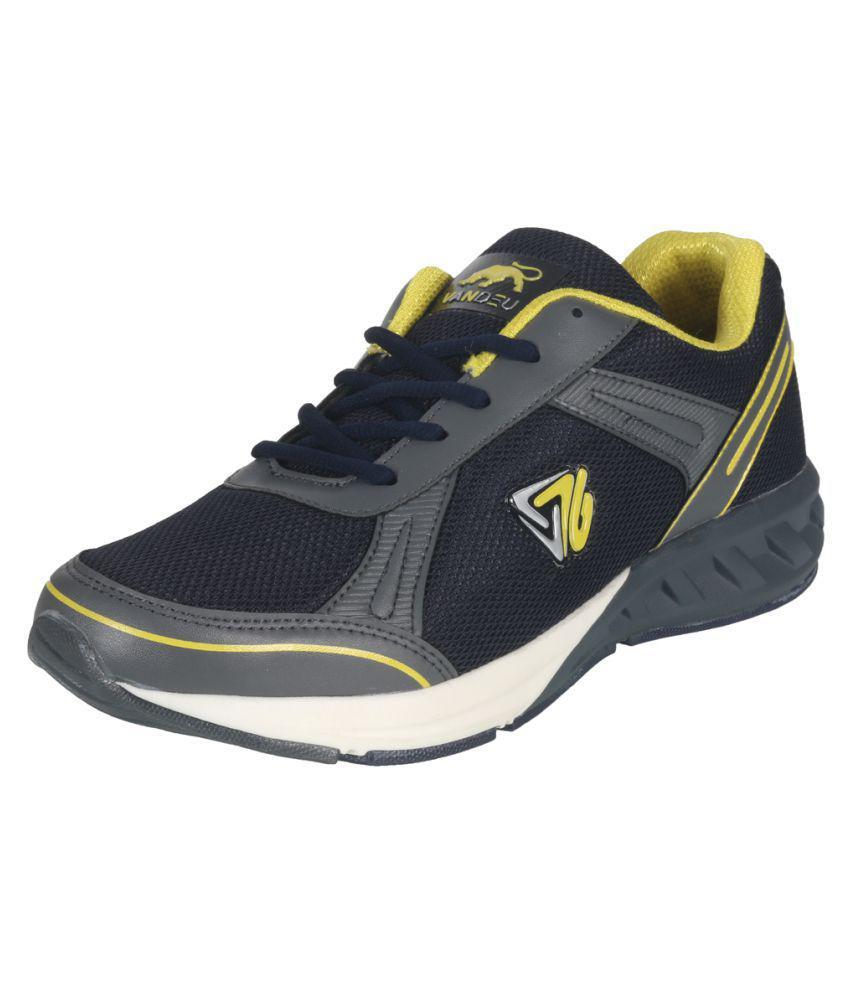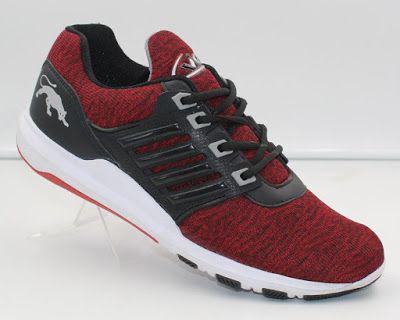The first image is the image on the left, the second image is the image on the right. Assess this claim about the two images: "The toe of the shoe in the image on the right is pointed to the left.". Correct or not? Answer yes or no. No. The first image is the image on the left, the second image is the image on the right. Analyze the images presented: Is the assertion "Right image contains one shoe tilted and facing rightward, with a cat silhouette somewhere on it." valid? Answer yes or no. Yes. 